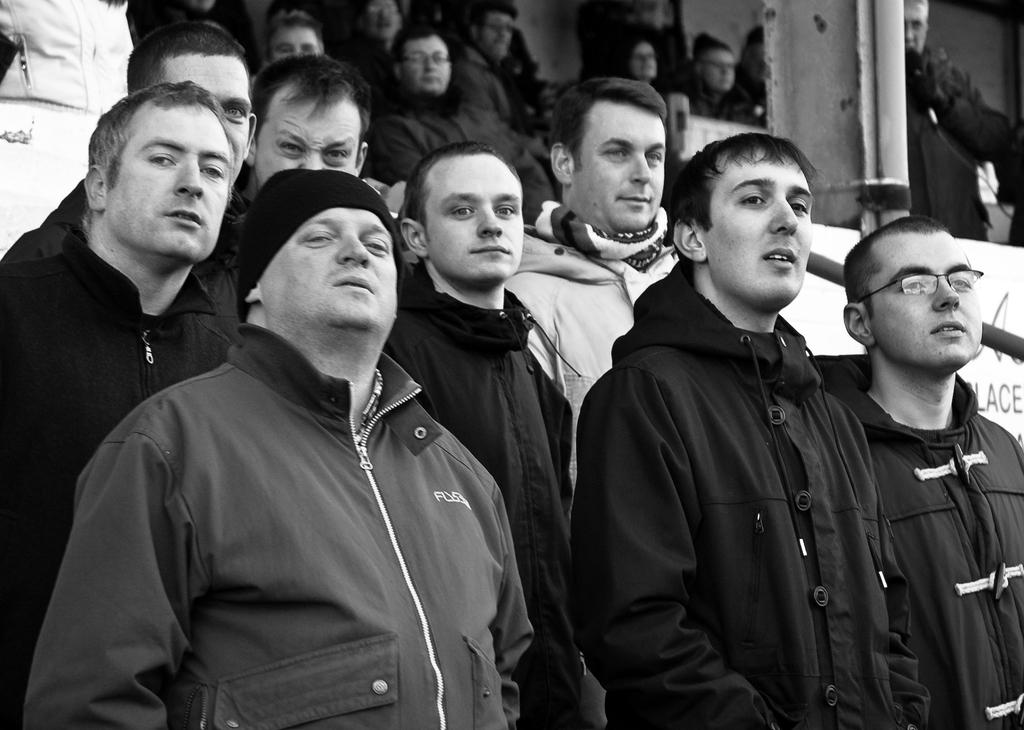What is the color scheme of the image? The image is black and white. What can be seen in the image besides the color scheme? There are people in the image. What object is located on the right side of the image? There appears to be a board on the right side of the image. What is written on the board? There is something written on the board. Can you tell me how many alleys are visible in the image? There are no alleys present in the image; it features a black and white scene with people and a board. What type of book is being read by the person on the left side of the image? There is no book visible in the image, as it only shows people and a board in a black and white setting. 